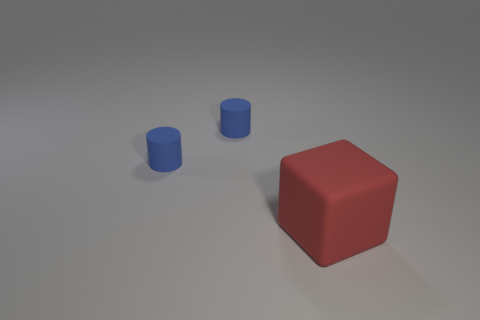The big object is what shape? The large object in the image is a cube. It has six faces, all of which are squares of the same size. It's a three-dimensional figure with equal edges, and each of the cube's vertices forms a right angle. 